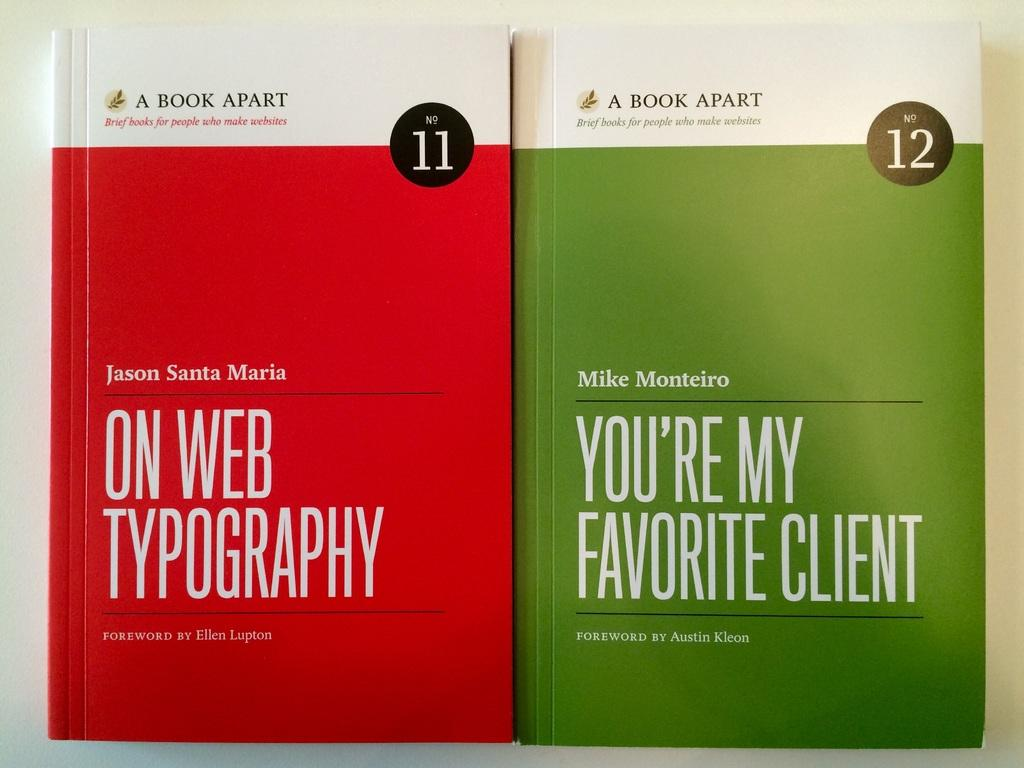Provide a one-sentence caption for the provided image. Two books with different colored covers reading ON WEB TYPOGRAPHY and YOU'RE MY FAVORITE CLIENT. 